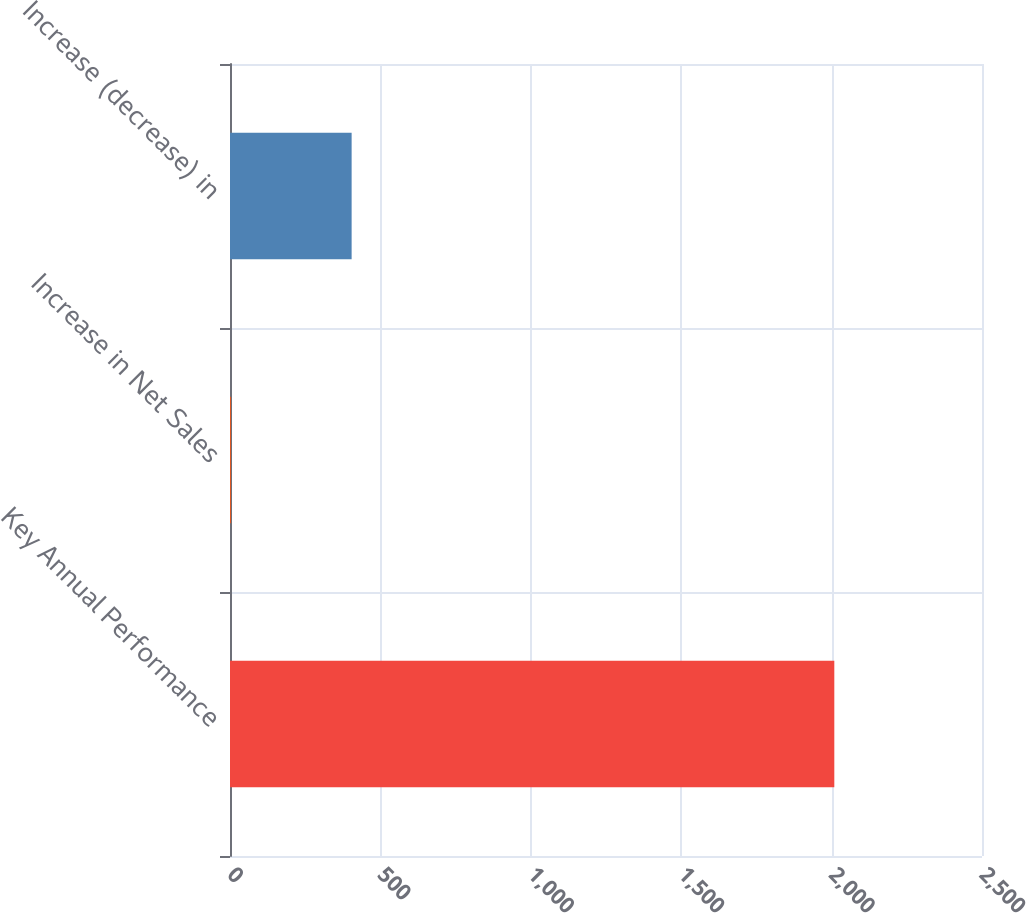<chart> <loc_0><loc_0><loc_500><loc_500><bar_chart><fcel>Key Annual Performance<fcel>Increase in Net Sales<fcel>Increase (decrease) in<nl><fcel>2009<fcel>3.2<fcel>404.36<nl></chart> 